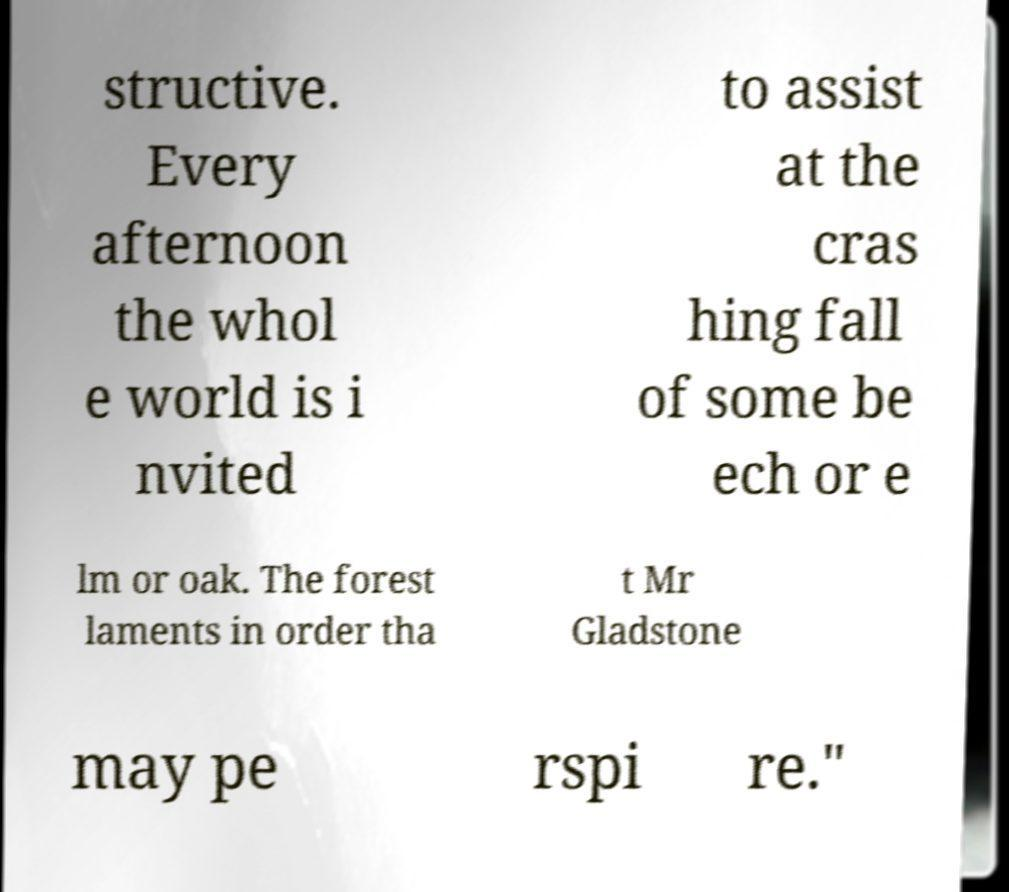For documentation purposes, I need the text within this image transcribed. Could you provide that? structive. Every afternoon the whol e world is i nvited to assist at the cras hing fall of some be ech or e lm or oak. The forest laments in order tha t Mr Gladstone may pe rspi re." 